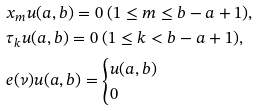Convert formula to latex. <formula><loc_0><loc_0><loc_500><loc_500>& x _ { m } u { ( a , b ) } = 0 \ ( 1 \leq m \leq b - a + 1 ) , \\ & \tau _ { k } u { ( a , b ) } = 0 \ ( 1 \leq k < b - a + 1 ) , \\ & e ( \nu ) u { ( a , b ) } = \begin{cases} u { ( a , b ) } & \\ 0 & \end{cases}</formula> 